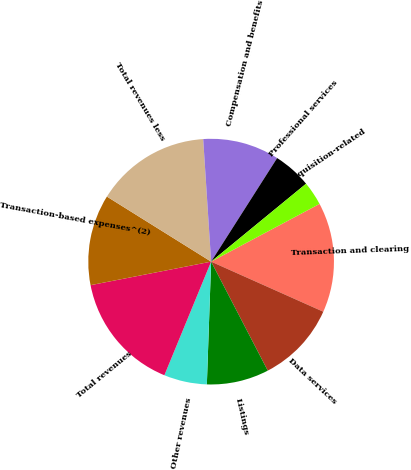<chart> <loc_0><loc_0><loc_500><loc_500><pie_chart><fcel>Transaction and clearing<fcel>Data services<fcel>Listings<fcel>Other revenues<fcel>Total revenues<fcel>Transaction-based expenses^(2)<fcel>Total revenues less<fcel>Compensation and benefits<fcel>Professional services<fcel>Acquisition-related<nl><fcel>14.47%<fcel>10.69%<fcel>8.18%<fcel>5.66%<fcel>15.72%<fcel>11.95%<fcel>15.09%<fcel>10.06%<fcel>5.03%<fcel>3.15%<nl></chart> 